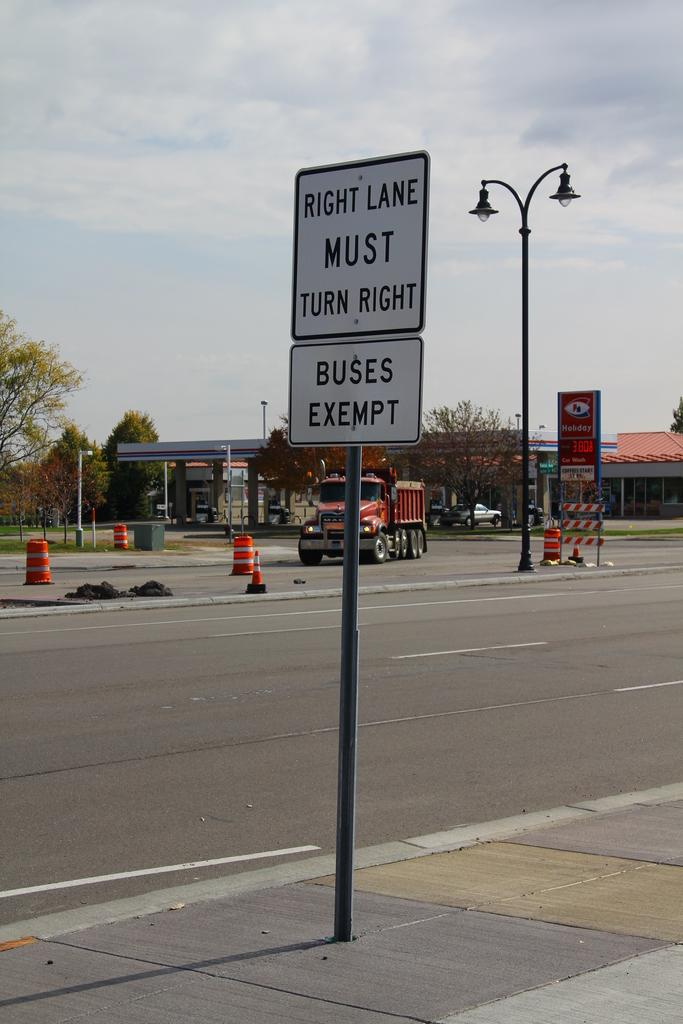What objects are on poles in the image? There are boards and lights on poles in the image. What objects are on the road in the image? There are traffic cones on the road in the image. What type of vehicle is visible in the image? A vehicle is visible in the image. What structures can be seen in the background of the image? There is a shed, a house, and trees in the background of the image. What type of lights are present in the background of the image? There are lights on poles in the background of the image. What other vehicle is visible in the background of the image? A car is visible in the background of the image. What part of the natural environment is visible in the background of the image? The sky is visible in the background of the image. What type of metal is the chicken using to build its nest in the image? There is no chicken present in the image, and therefore no such activity can be observed. Can you provide an example of a different type of vehicle that could be present in the image? The image already shows a vehicle and a car, so it's not possible to provide an example of a different type of vehicle that could be present in the image. 